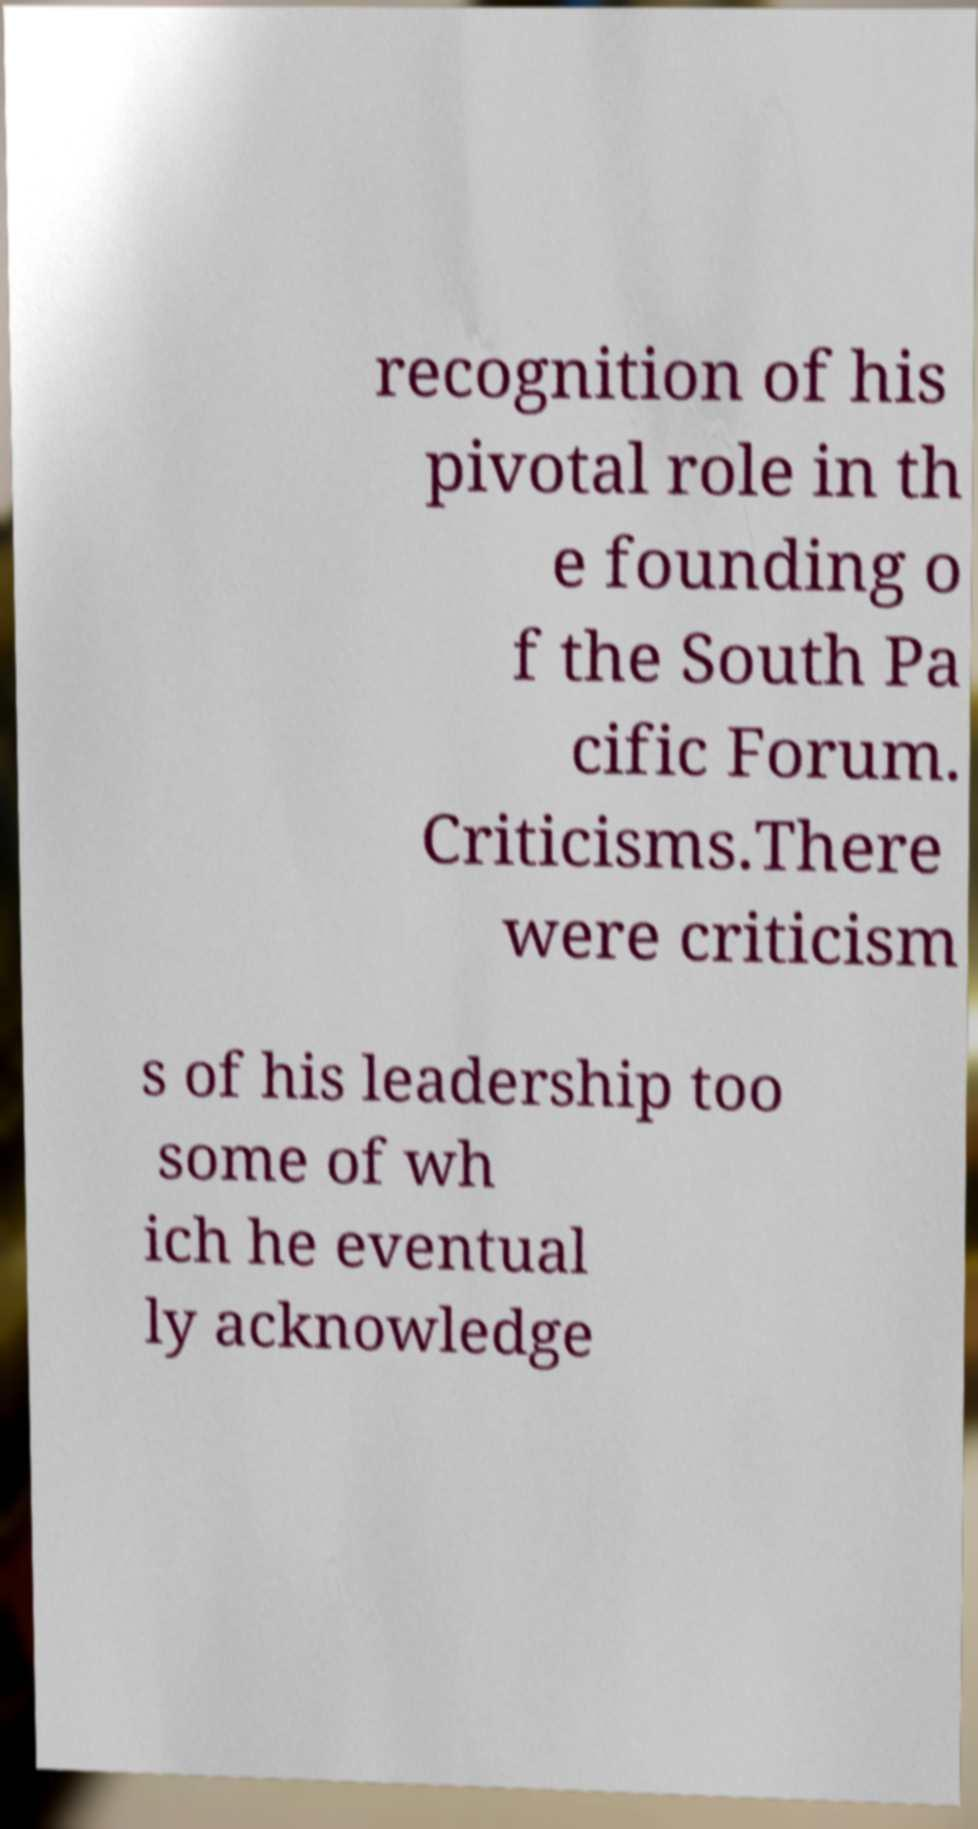I need the written content from this picture converted into text. Can you do that? recognition of his pivotal role in th e founding o f the South Pa cific Forum. Criticisms.There were criticism s of his leadership too some of wh ich he eventual ly acknowledge 